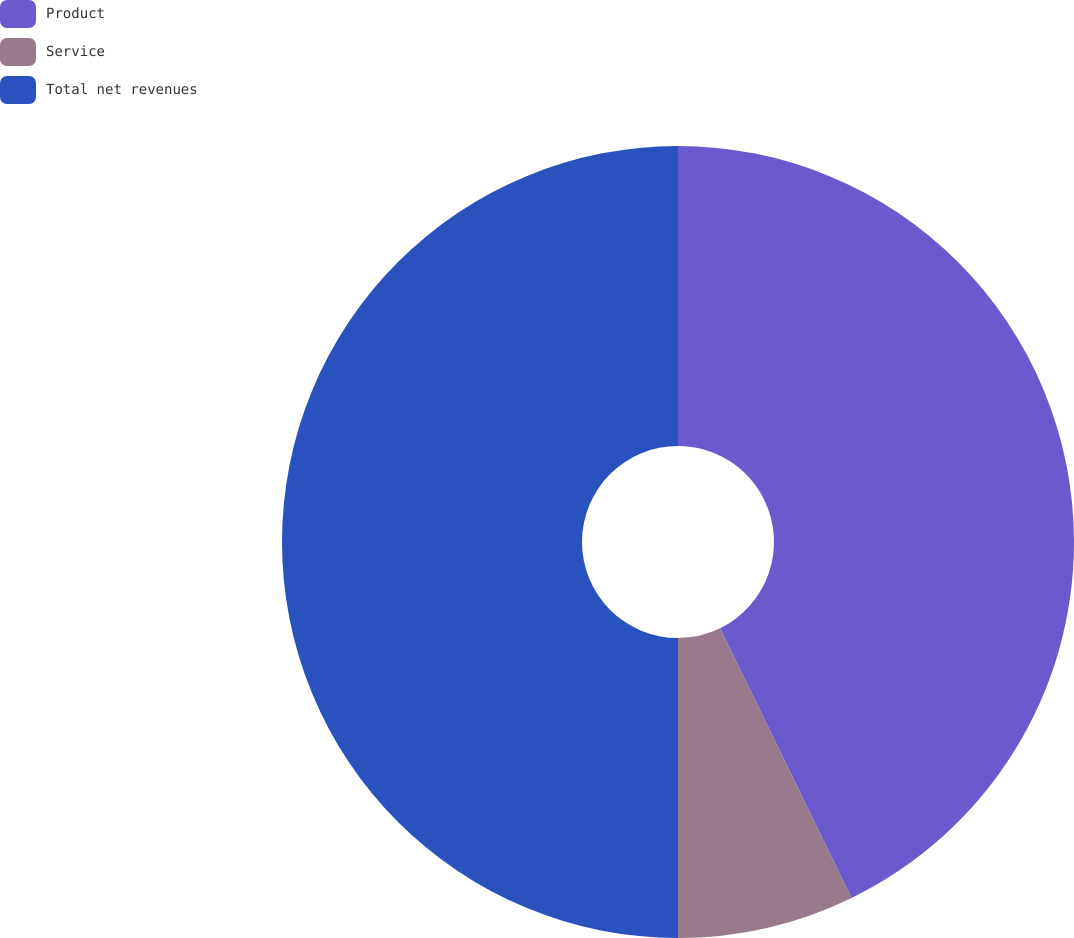Convert chart to OTSL. <chart><loc_0><loc_0><loc_500><loc_500><pie_chart><fcel>Product<fcel>Service<fcel>Total net revenues<nl><fcel>42.78%<fcel>7.22%<fcel>50.0%<nl></chart> 